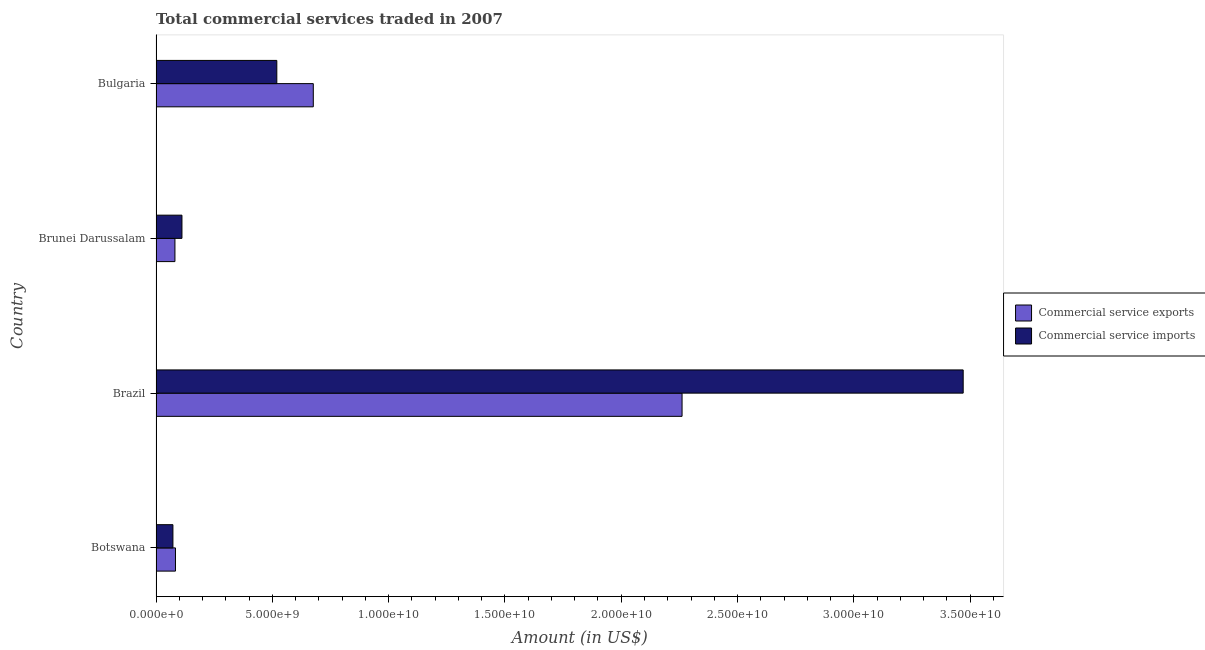How many bars are there on the 4th tick from the bottom?
Give a very brief answer. 2. What is the amount of commercial service exports in Bulgaria?
Offer a terse response. 6.76e+09. Across all countries, what is the maximum amount of commercial service exports?
Ensure brevity in your answer.  2.26e+1. Across all countries, what is the minimum amount of commercial service imports?
Provide a short and direct response. 7.27e+08. In which country was the amount of commercial service exports maximum?
Give a very brief answer. Brazil. In which country was the amount of commercial service exports minimum?
Your answer should be compact. Brunei Darussalam. What is the total amount of commercial service exports in the graph?
Offer a very short reply. 3.10e+1. What is the difference between the amount of commercial service imports in Botswana and that in Bulgaria?
Provide a short and direct response. -4.47e+09. What is the difference between the amount of commercial service exports in Botswana and the amount of commercial service imports in Brunei Darussalam?
Offer a very short reply. -2.79e+08. What is the average amount of commercial service exports per country?
Your response must be concise. 7.76e+09. What is the difference between the amount of commercial service imports and amount of commercial service exports in Brunei Darussalam?
Provide a succinct answer. 3.02e+08. What is the ratio of the amount of commercial service imports in Botswana to that in Brazil?
Your response must be concise. 0.02. Is the amount of commercial service imports in Brazil less than that in Bulgaria?
Make the answer very short. No. What is the difference between the highest and the second highest amount of commercial service imports?
Your answer should be very brief. 2.95e+1. What is the difference between the highest and the lowest amount of commercial service exports?
Keep it short and to the point. 2.18e+1. What does the 2nd bar from the top in Brunei Darussalam represents?
Provide a succinct answer. Commercial service exports. What does the 1st bar from the bottom in Brazil represents?
Your answer should be compact. Commercial service exports. How many bars are there?
Provide a succinct answer. 8. Are all the bars in the graph horizontal?
Keep it short and to the point. Yes. How many countries are there in the graph?
Ensure brevity in your answer.  4. Are the values on the major ticks of X-axis written in scientific E-notation?
Your answer should be very brief. Yes. Does the graph contain grids?
Your answer should be very brief. No. What is the title of the graph?
Make the answer very short. Total commercial services traded in 2007. Does "Tetanus" appear as one of the legend labels in the graph?
Provide a short and direct response. No. What is the label or title of the Y-axis?
Your answer should be very brief. Country. What is the Amount (in US$) in Commercial service exports in Botswana?
Keep it short and to the point. 8.36e+08. What is the Amount (in US$) in Commercial service imports in Botswana?
Provide a short and direct response. 7.27e+08. What is the Amount (in US$) of Commercial service exports in Brazil?
Ensure brevity in your answer.  2.26e+1. What is the Amount (in US$) of Commercial service imports in Brazil?
Provide a succinct answer. 3.47e+1. What is the Amount (in US$) in Commercial service exports in Brunei Darussalam?
Your response must be concise. 8.13e+08. What is the Amount (in US$) of Commercial service imports in Brunei Darussalam?
Your answer should be compact. 1.12e+09. What is the Amount (in US$) of Commercial service exports in Bulgaria?
Give a very brief answer. 6.76e+09. What is the Amount (in US$) of Commercial service imports in Bulgaria?
Ensure brevity in your answer.  5.19e+09. Across all countries, what is the maximum Amount (in US$) in Commercial service exports?
Keep it short and to the point. 2.26e+1. Across all countries, what is the maximum Amount (in US$) in Commercial service imports?
Make the answer very short. 3.47e+1. Across all countries, what is the minimum Amount (in US$) of Commercial service exports?
Your answer should be compact. 8.13e+08. Across all countries, what is the minimum Amount (in US$) of Commercial service imports?
Provide a short and direct response. 7.27e+08. What is the total Amount (in US$) of Commercial service exports in the graph?
Your response must be concise. 3.10e+1. What is the total Amount (in US$) in Commercial service imports in the graph?
Your answer should be compact. 4.17e+1. What is the difference between the Amount (in US$) of Commercial service exports in Botswana and that in Brazil?
Make the answer very short. -2.18e+1. What is the difference between the Amount (in US$) of Commercial service imports in Botswana and that in Brazil?
Make the answer very short. -3.40e+1. What is the difference between the Amount (in US$) of Commercial service exports in Botswana and that in Brunei Darussalam?
Your answer should be very brief. 2.26e+07. What is the difference between the Amount (in US$) in Commercial service imports in Botswana and that in Brunei Darussalam?
Keep it short and to the point. -3.88e+08. What is the difference between the Amount (in US$) of Commercial service exports in Botswana and that in Bulgaria?
Give a very brief answer. -5.93e+09. What is the difference between the Amount (in US$) in Commercial service imports in Botswana and that in Bulgaria?
Ensure brevity in your answer.  -4.47e+09. What is the difference between the Amount (in US$) of Commercial service exports in Brazil and that in Brunei Darussalam?
Offer a terse response. 2.18e+1. What is the difference between the Amount (in US$) in Commercial service imports in Brazil and that in Brunei Darussalam?
Provide a short and direct response. 3.36e+1. What is the difference between the Amount (in US$) of Commercial service exports in Brazil and that in Bulgaria?
Your answer should be very brief. 1.59e+1. What is the difference between the Amount (in US$) in Commercial service imports in Brazil and that in Bulgaria?
Make the answer very short. 2.95e+1. What is the difference between the Amount (in US$) of Commercial service exports in Brunei Darussalam and that in Bulgaria?
Your response must be concise. -5.95e+09. What is the difference between the Amount (in US$) of Commercial service imports in Brunei Darussalam and that in Bulgaria?
Keep it short and to the point. -4.08e+09. What is the difference between the Amount (in US$) in Commercial service exports in Botswana and the Amount (in US$) in Commercial service imports in Brazil?
Make the answer very short. -3.39e+1. What is the difference between the Amount (in US$) of Commercial service exports in Botswana and the Amount (in US$) of Commercial service imports in Brunei Darussalam?
Offer a terse response. -2.79e+08. What is the difference between the Amount (in US$) of Commercial service exports in Botswana and the Amount (in US$) of Commercial service imports in Bulgaria?
Keep it short and to the point. -4.36e+09. What is the difference between the Amount (in US$) of Commercial service exports in Brazil and the Amount (in US$) of Commercial service imports in Brunei Darussalam?
Ensure brevity in your answer.  2.15e+1. What is the difference between the Amount (in US$) of Commercial service exports in Brazil and the Amount (in US$) of Commercial service imports in Bulgaria?
Your response must be concise. 1.74e+1. What is the difference between the Amount (in US$) of Commercial service exports in Brunei Darussalam and the Amount (in US$) of Commercial service imports in Bulgaria?
Make the answer very short. -4.38e+09. What is the average Amount (in US$) in Commercial service exports per country?
Provide a succinct answer. 7.76e+09. What is the average Amount (in US$) in Commercial service imports per country?
Offer a very short reply. 1.04e+1. What is the difference between the Amount (in US$) in Commercial service exports and Amount (in US$) in Commercial service imports in Botswana?
Ensure brevity in your answer.  1.09e+08. What is the difference between the Amount (in US$) of Commercial service exports and Amount (in US$) of Commercial service imports in Brazil?
Your answer should be very brief. -1.21e+1. What is the difference between the Amount (in US$) in Commercial service exports and Amount (in US$) in Commercial service imports in Brunei Darussalam?
Keep it short and to the point. -3.02e+08. What is the difference between the Amount (in US$) in Commercial service exports and Amount (in US$) in Commercial service imports in Bulgaria?
Ensure brevity in your answer.  1.57e+09. What is the ratio of the Amount (in US$) of Commercial service exports in Botswana to that in Brazil?
Offer a terse response. 0.04. What is the ratio of the Amount (in US$) in Commercial service imports in Botswana to that in Brazil?
Your response must be concise. 0.02. What is the ratio of the Amount (in US$) of Commercial service exports in Botswana to that in Brunei Darussalam?
Offer a very short reply. 1.03. What is the ratio of the Amount (in US$) of Commercial service imports in Botswana to that in Brunei Darussalam?
Give a very brief answer. 0.65. What is the ratio of the Amount (in US$) in Commercial service exports in Botswana to that in Bulgaria?
Your answer should be very brief. 0.12. What is the ratio of the Amount (in US$) of Commercial service imports in Botswana to that in Bulgaria?
Provide a succinct answer. 0.14. What is the ratio of the Amount (in US$) in Commercial service exports in Brazil to that in Brunei Darussalam?
Provide a succinct answer. 27.8. What is the ratio of the Amount (in US$) in Commercial service imports in Brazil to that in Brunei Darussalam?
Offer a terse response. 31.12. What is the ratio of the Amount (in US$) in Commercial service exports in Brazil to that in Bulgaria?
Your answer should be very brief. 3.34. What is the ratio of the Amount (in US$) in Commercial service imports in Brazil to that in Bulgaria?
Offer a very short reply. 6.68. What is the ratio of the Amount (in US$) of Commercial service exports in Brunei Darussalam to that in Bulgaria?
Your response must be concise. 0.12. What is the ratio of the Amount (in US$) in Commercial service imports in Brunei Darussalam to that in Bulgaria?
Provide a short and direct response. 0.21. What is the difference between the highest and the second highest Amount (in US$) in Commercial service exports?
Your answer should be very brief. 1.59e+1. What is the difference between the highest and the second highest Amount (in US$) of Commercial service imports?
Your answer should be compact. 2.95e+1. What is the difference between the highest and the lowest Amount (in US$) in Commercial service exports?
Your answer should be compact. 2.18e+1. What is the difference between the highest and the lowest Amount (in US$) in Commercial service imports?
Your answer should be compact. 3.40e+1. 